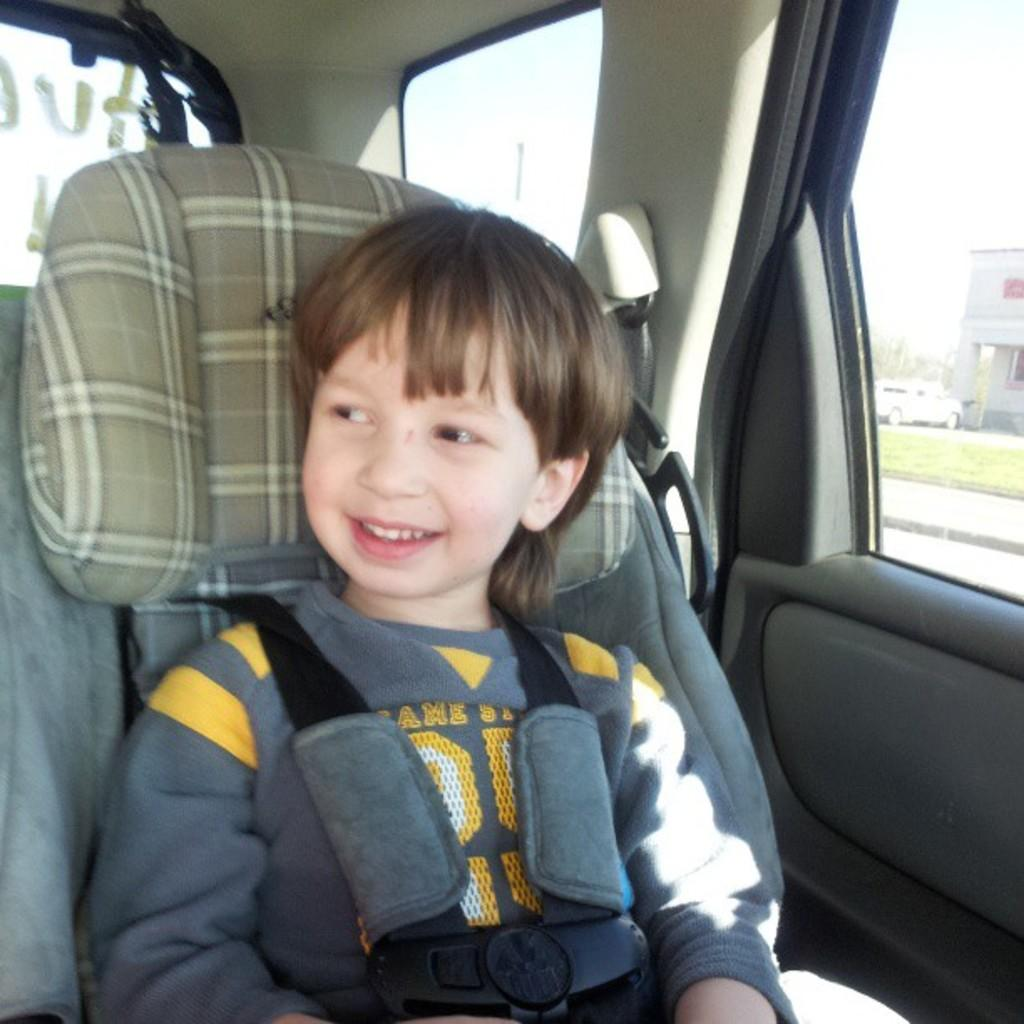What is the kid doing in the image? The kid is sitting inside a car. What can be seen outside the car window? There is a vehicle and a building visible outside the car window, as well as grass. Can you describe the surroundings of the car? The surroundings include a vehicle, a building, and grass. How does the kid's nervous system compare to the bike outside the car window? There is no bike present in the image, and the kid's nervous system is not visible or relevant to the image. 